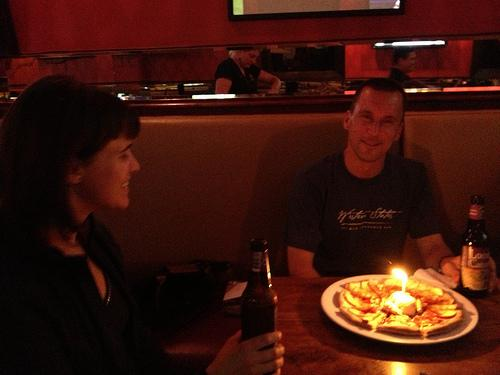In a poetic manner, describe the key aspects of the image. In a quaint eatery's warm embrace, a man and lady sit with grace; a wooden table bears their fare, a birthday pizza lit with care; each with a beer, they raise a toast, to moments they will cherish most. Imagine a dialogue between the two people in the image about what is happening. Man: "Thank you, darling! All the more special sharing it with you and our beers at this lovely restaurant." Use a humorous tone to describe the central concept of the image. Who needs a birthday cake when you can have a birthday pizza with a lit candle, right? It's a sweet celebration as this couple clinks their beer bottles and savors their unconventional treat! Mention the primary elements present in the setting of the image and their relationship with each other. A man and woman are sitting at a wooden table in a restaurant, with a white circular plate containing sliced birthday pizza and a lit candle, as they hold beer bottles in their hands. Narrate the scene depicted in the picture using a casual and conversational tone. Oh, look! There's a couple enjoying some birthday pizza with a lit candle on it and having beers in their hands, sitting at a wooden table in a cozy restaurant. Express the main theme of the image in a question form. Are the man and woman at the wooden table celebrating a birthday with a lit candle on a sliced pizza and holding beers in their hands? List down five essential aspects of the image in bullet points. - Smiling faces of the man and woman As if you are explaining the scene to a child, describe the essential components of the image. Sweetie, the picture shows a man and a woman sitting at a table with a big pizza that has a birthday candle on it. They are also holding special drinks called beer in their hands and seem to be having a fun time. Describe the key elements of the image as if you are narrating it to someone who cannot see it. Picture this: a couple is sitting in a restaurant, with a wooden table in front of them. On the table, there's a white circular plate displaying a birthday pizza with a lit candle on it. The man and the woman are joyously holding beer bottles in their hands as they celebrate. Briefly mention the primary action taking place in the image and the people involved in it. A man and a woman are enjoying a birthday celebration at a restaurant, featuring a pizza with a lit candle and beer bottles in their hands. Is there a white rectangular plate on the wooden table? The plate is described as white and circular, not rectangular. The beer bottles in their hands are green. No, it's not mentioned in the image. Can you find a bald man in the image? There is a man with very short hair, but not a bald man. Does the man have curly hair and beard? There's information about men with very short hair and brown hair, but nothing about curly hair or beard. Notice a logo on the woman's black shirt. The logo is described on the man's shirt, not the woman's black shirt. Observe a candle without a flame on the pizza. The candle is described as lit, meaning it has a flame. The pizza has only one slice remaining on the plate. The pizza is described as being cut into slices, but there is no information about how many slices remain. Both people are holding their beers with their left hands. The man is holding a beer in his left hand, but the woman is holding it in her right hand. The woman with dark hair is wearing a red dress. The woman is described wearing a black shirt, not a red dress. 